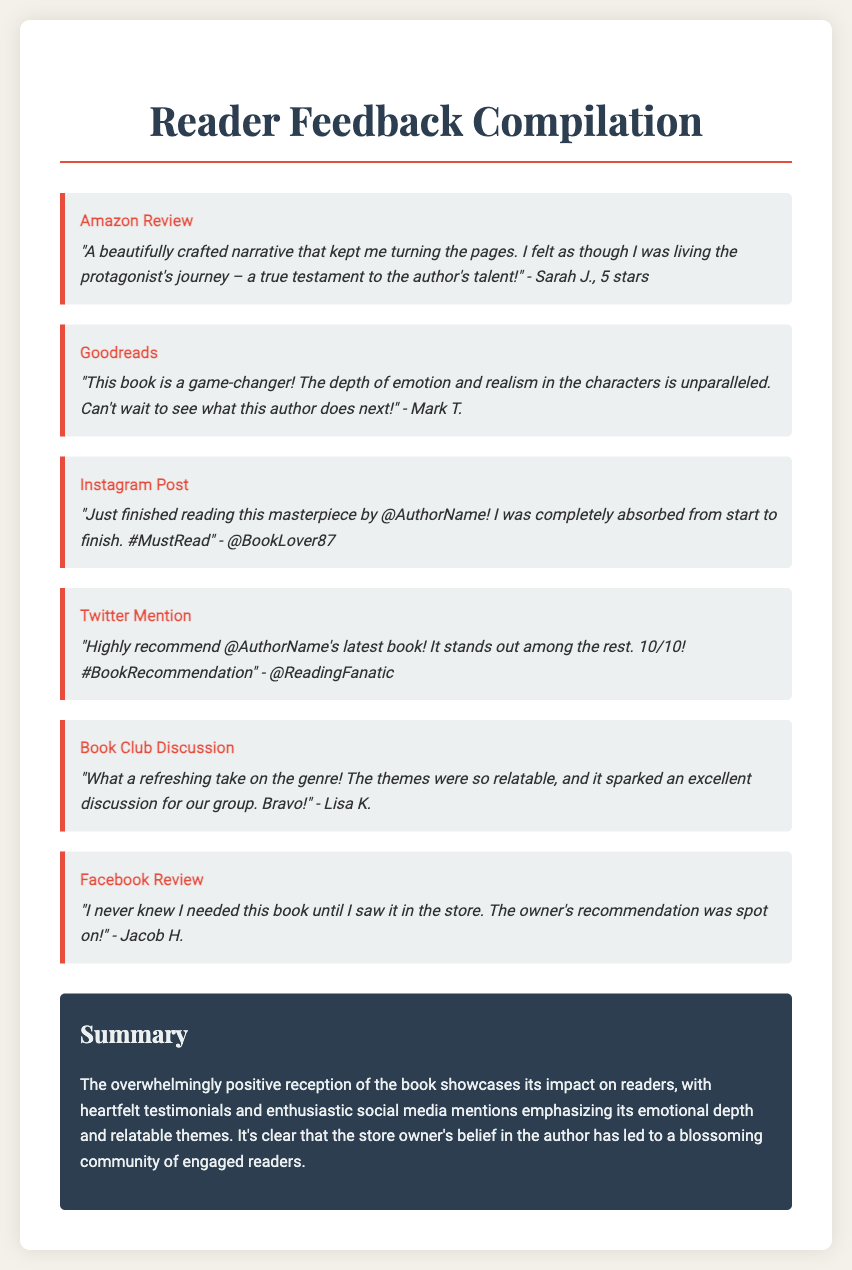What is the title of the document? The title of the document is prominently displayed at the top of the page.
Answer: Reader Feedback Compilation How many stars did Sarah J. give the book? Sarah J. provided a star rating in her review of the book.
Answer: 5 stars Which social media platform does @BookLover87 use? The feedback from @BookLover87 indicates the specific platform where the mention was made.
Answer: Instagram What is a key theme mentioned in the feedback? Multiple feedback items highlight recurring themes present in the reader's responses.
Answer: Relatable Who mentioned that the book was a game-changer? The feedback reveals who referred to the book as a game-changer in their review.
Answer: Mark T What was the sentiment of Jacob H.'s review? Jacob H.'s review reflects his feelings based on his experience with the book and its recommendation.
Answer: Positive What color is the summary box? The summary section has a distinct background color correlating with the overall style of the document.
Answer: Dark blue Which reader commented about a book club discussion? Feedback from a reader provides information about a discussion that took place in a book club setting.
Answer: Lisa K What does the summary indicate about the store owner's belief? The summary provides insight into the impact of the store owner's actions on the success of the book and community.
Answer: Blossoming community 